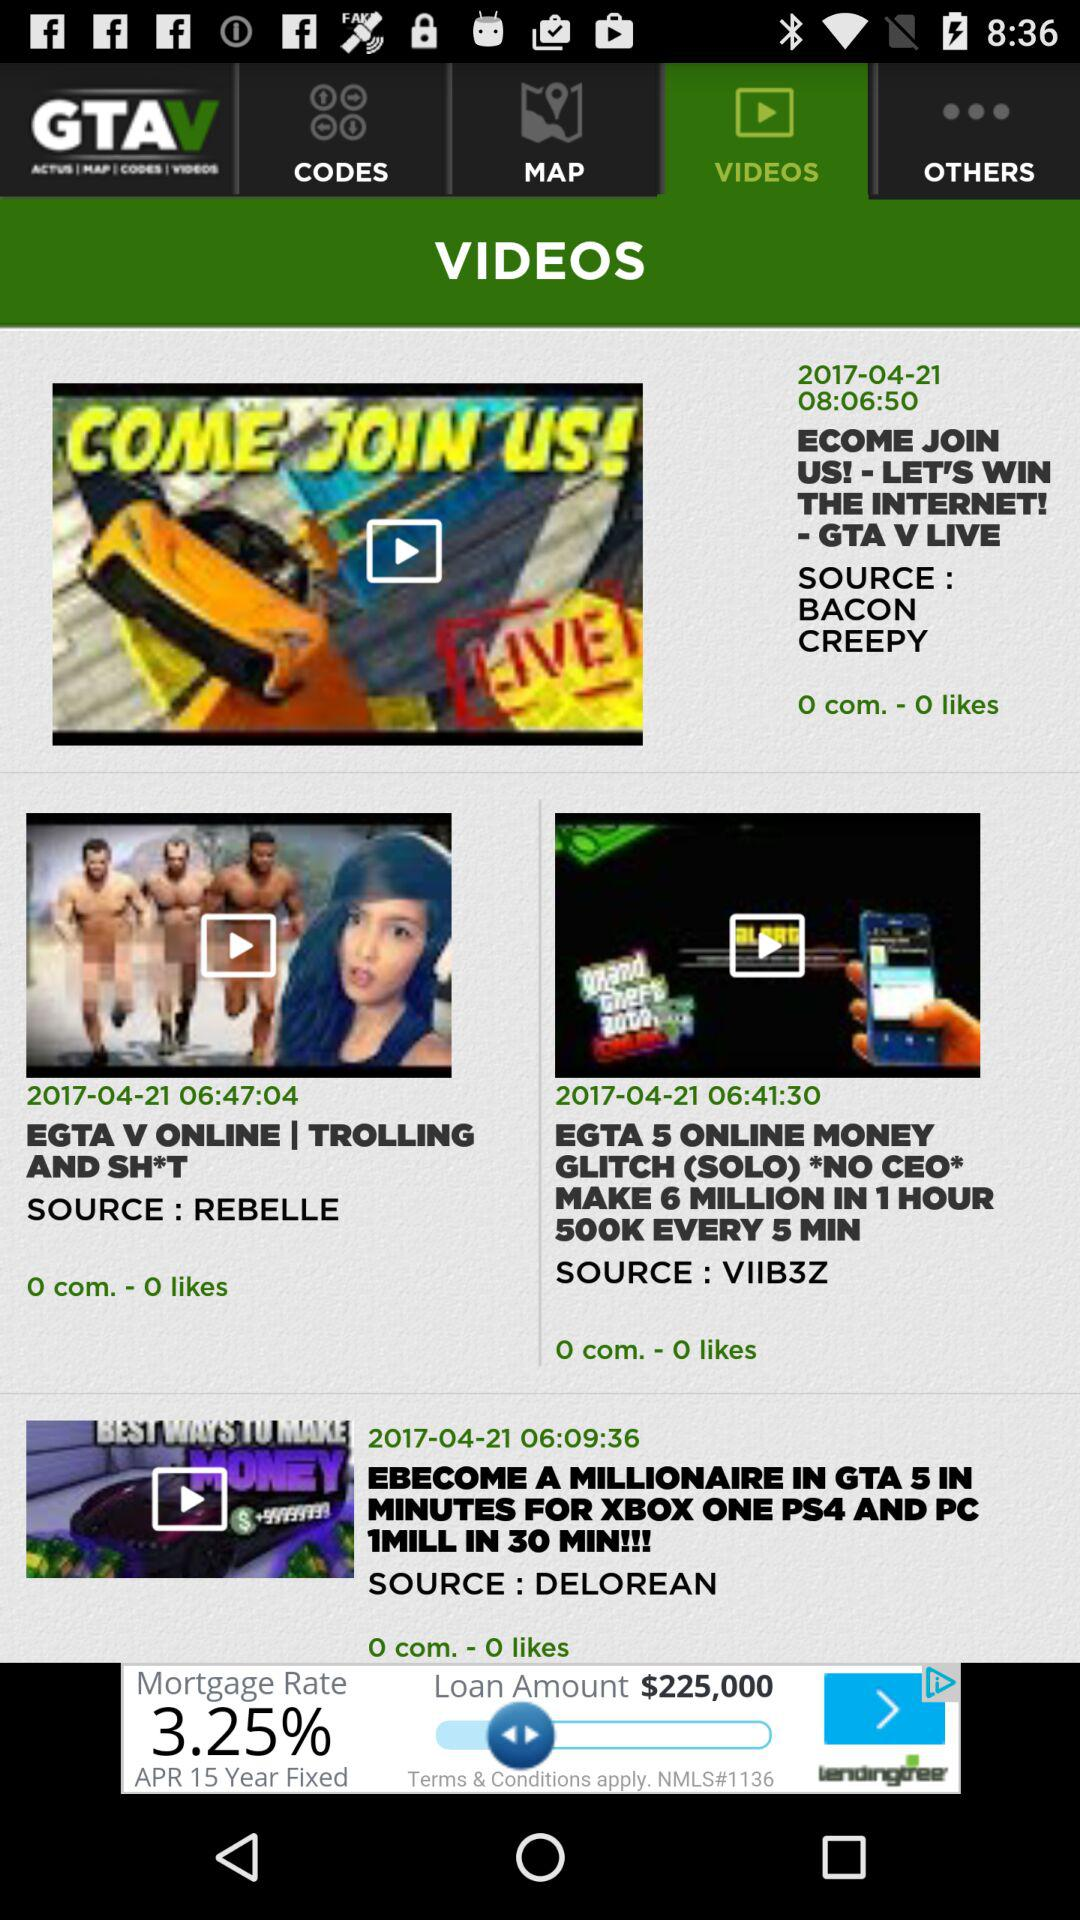How many likes have been given to the video titled "EGTA V ONLINE | TROLLING AND SH*T"? There are 0 likes given to the video. 